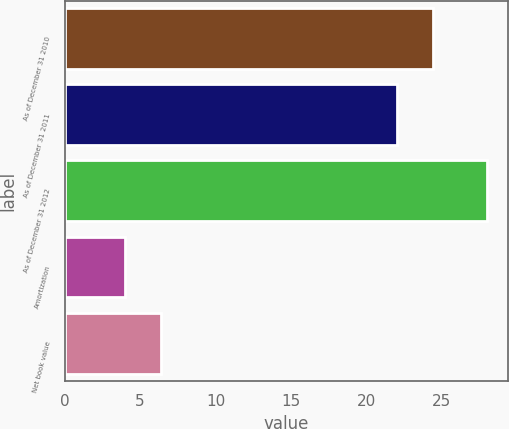<chart> <loc_0><loc_0><loc_500><loc_500><bar_chart><fcel>As of December 31 2010<fcel>As of December 31 2011<fcel>As of December 31 2012<fcel>Amortization<fcel>Net book value<nl><fcel>24.4<fcel>22<fcel>28<fcel>4<fcel>6.4<nl></chart> 